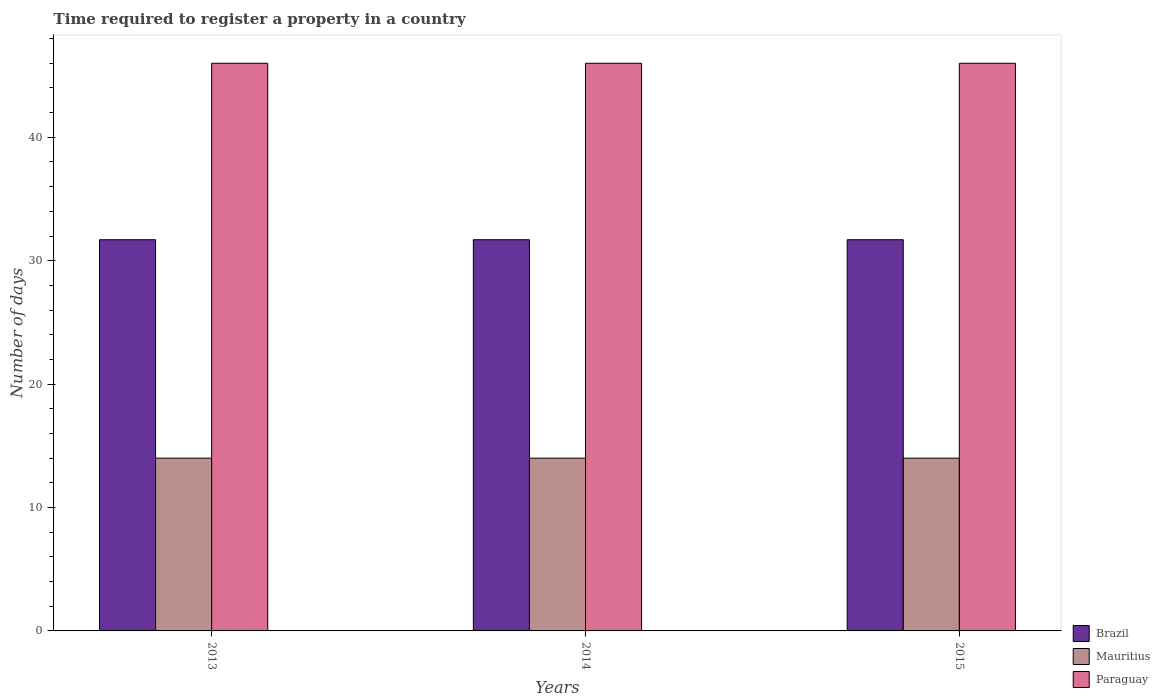How many different coloured bars are there?
Provide a short and direct response. 3. How many groups of bars are there?
Provide a short and direct response. 3. How many bars are there on the 2nd tick from the left?
Your answer should be very brief. 3. What is the label of the 1st group of bars from the left?
Your response must be concise. 2013. In how many cases, is the number of bars for a given year not equal to the number of legend labels?
Your response must be concise. 0. What is the number of days required to register a property in Mauritius in 2015?
Ensure brevity in your answer.  14. Across all years, what is the maximum number of days required to register a property in Brazil?
Your response must be concise. 31.7. Across all years, what is the minimum number of days required to register a property in Paraguay?
Your answer should be compact. 46. In which year was the number of days required to register a property in Paraguay maximum?
Provide a succinct answer. 2013. What is the total number of days required to register a property in Paraguay in the graph?
Your response must be concise. 138. What is the difference between the number of days required to register a property in Mauritius in 2014 and that in 2015?
Offer a very short reply. 0. What is the difference between the number of days required to register a property in Brazil in 2015 and the number of days required to register a property in Mauritius in 2014?
Keep it short and to the point. 17.7. In the year 2015, what is the difference between the number of days required to register a property in Brazil and number of days required to register a property in Mauritius?
Your response must be concise. 17.7. In how many years, is the number of days required to register a property in Mauritius greater than 16 days?
Keep it short and to the point. 0. Is the number of days required to register a property in Mauritius in 2014 less than that in 2015?
Provide a short and direct response. No. Is the difference between the number of days required to register a property in Brazil in 2014 and 2015 greater than the difference between the number of days required to register a property in Mauritius in 2014 and 2015?
Offer a terse response. No. What is the difference between the highest and the second highest number of days required to register a property in Brazil?
Your answer should be very brief. 0. What is the difference between the highest and the lowest number of days required to register a property in Brazil?
Give a very brief answer. 0. In how many years, is the number of days required to register a property in Brazil greater than the average number of days required to register a property in Brazil taken over all years?
Your answer should be compact. 0. Is the sum of the number of days required to register a property in Brazil in 2013 and 2015 greater than the maximum number of days required to register a property in Paraguay across all years?
Ensure brevity in your answer.  Yes. What does the 2nd bar from the left in 2013 represents?
Keep it short and to the point. Mauritius. What does the 3rd bar from the right in 2014 represents?
Keep it short and to the point. Brazil. Is it the case that in every year, the sum of the number of days required to register a property in Paraguay and number of days required to register a property in Mauritius is greater than the number of days required to register a property in Brazil?
Offer a terse response. Yes. How many bars are there?
Your response must be concise. 9. Are all the bars in the graph horizontal?
Keep it short and to the point. No. How many years are there in the graph?
Ensure brevity in your answer.  3. What is the difference between two consecutive major ticks on the Y-axis?
Your response must be concise. 10. Does the graph contain any zero values?
Your answer should be compact. No. Where does the legend appear in the graph?
Offer a terse response. Bottom right. What is the title of the graph?
Your response must be concise. Time required to register a property in a country. Does "Lebanon" appear as one of the legend labels in the graph?
Provide a short and direct response. No. What is the label or title of the Y-axis?
Provide a succinct answer. Number of days. What is the Number of days in Brazil in 2013?
Your response must be concise. 31.7. What is the Number of days in Mauritius in 2013?
Your response must be concise. 14. What is the Number of days of Brazil in 2014?
Offer a very short reply. 31.7. What is the Number of days in Brazil in 2015?
Your answer should be compact. 31.7. What is the Number of days of Mauritius in 2015?
Your response must be concise. 14. Across all years, what is the maximum Number of days in Brazil?
Ensure brevity in your answer.  31.7. Across all years, what is the maximum Number of days in Paraguay?
Your answer should be very brief. 46. Across all years, what is the minimum Number of days in Brazil?
Your answer should be very brief. 31.7. Across all years, what is the minimum Number of days in Mauritius?
Offer a very short reply. 14. What is the total Number of days in Brazil in the graph?
Ensure brevity in your answer.  95.1. What is the total Number of days in Mauritius in the graph?
Make the answer very short. 42. What is the total Number of days in Paraguay in the graph?
Provide a succinct answer. 138. What is the difference between the Number of days in Brazil in 2013 and that in 2014?
Provide a succinct answer. 0. What is the difference between the Number of days in Paraguay in 2013 and that in 2014?
Provide a succinct answer. 0. What is the difference between the Number of days of Mauritius in 2014 and that in 2015?
Give a very brief answer. 0. What is the difference between the Number of days of Paraguay in 2014 and that in 2015?
Your answer should be compact. 0. What is the difference between the Number of days in Brazil in 2013 and the Number of days in Mauritius in 2014?
Make the answer very short. 17.7. What is the difference between the Number of days in Brazil in 2013 and the Number of days in Paraguay in 2014?
Provide a succinct answer. -14.3. What is the difference between the Number of days in Mauritius in 2013 and the Number of days in Paraguay in 2014?
Make the answer very short. -32. What is the difference between the Number of days in Brazil in 2013 and the Number of days in Paraguay in 2015?
Keep it short and to the point. -14.3. What is the difference between the Number of days of Mauritius in 2013 and the Number of days of Paraguay in 2015?
Your answer should be very brief. -32. What is the difference between the Number of days of Brazil in 2014 and the Number of days of Paraguay in 2015?
Offer a terse response. -14.3. What is the difference between the Number of days in Mauritius in 2014 and the Number of days in Paraguay in 2015?
Keep it short and to the point. -32. What is the average Number of days of Brazil per year?
Keep it short and to the point. 31.7. What is the average Number of days in Mauritius per year?
Ensure brevity in your answer.  14. What is the average Number of days in Paraguay per year?
Your answer should be very brief. 46. In the year 2013, what is the difference between the Number of days in Brazil and Number of days in Mauritius?
Your response must be concise. 17.7. In the year 2013, what is the difference between the Number of days in Brazil and Number of days in Paraguay?
Offer a terse response. -14.3. In the year 2013, what is the difference between the Number of days of Mauritius and Number of days of Paraguay?
Provide a short and direct response. -32. In the year 2014, what is the difference between the Number of days of Brazil and Number of days of Mauritius?
Keep it short and to the point. 17.7. In the year 2014, what is the difference between the Number of days of Brazil and Number of days of Paraguay?
Your answer should be compact. -14.3. In the year 2014, what is the difference between the Number of days in Mauritius and Number of days in Paraguay?
Ensure brevity in your answer.  -32. In the year 2015, what is the difference between the Number of days in Brazil and Number of days in Mauritius?
Keep it short and to the point. 17.7. In the year 2015, what is the difference between the Number of days of Brazil and Number of days of Paraguay?
Ensure brevity in your answer.  -14.3. In the year 2015, what is the difference between the Number of days in Mauritius and Number of days in Paraguay?
Make the answer very short. -32. What is the ratio of the Number of days of Paraguay in 2013 to that in 2014?
Make the answer very short. 1. What is the ratio of the Number of days in Brazil in 2014 to that in 2015?
Your answer should be very brief. 1. What is the ratio of the Number of days of Mauritius in 2014 to that in 2015?
Give a very brief answer. 1. What is the difference between the highest and the second highest Number of days in Paraguay?
Provide a short and direct response. 0. What is the difference between the highest and the lowest Number of days of Mauritius?
Give a very brief answer. 0. 